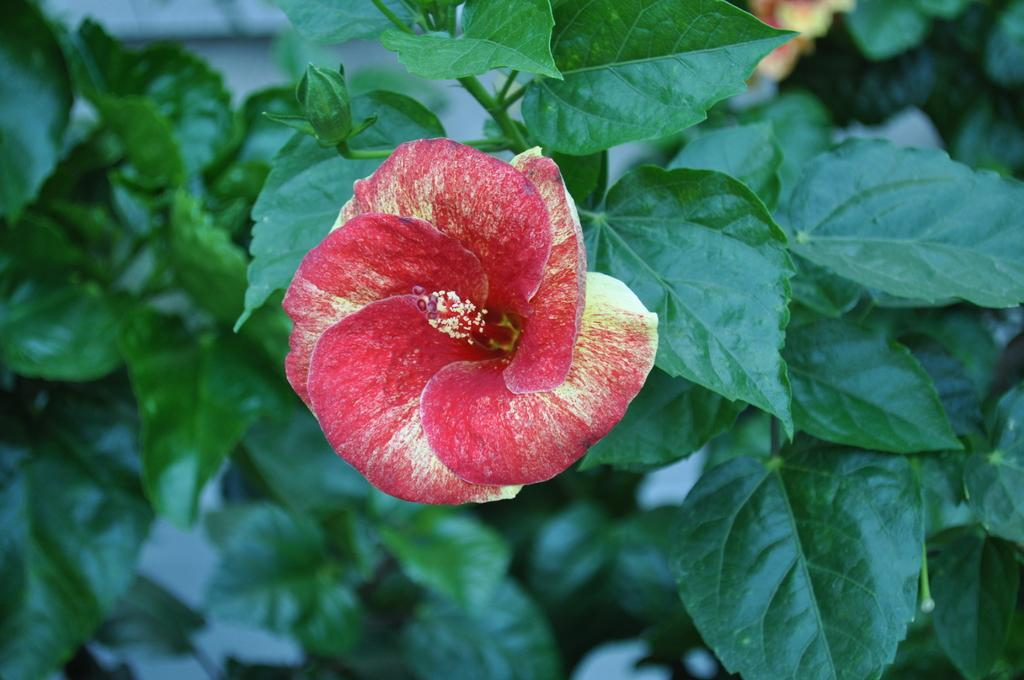What type of flower is depicted in the picture? There is a shoe flower in the picture. What else can be seen in the picture besides the flower? There are leaves in the picture. How would you describe the background of the image? The backdrop is blurred. Where is the mailbox located in the image? There is no mailbox present in the image. 